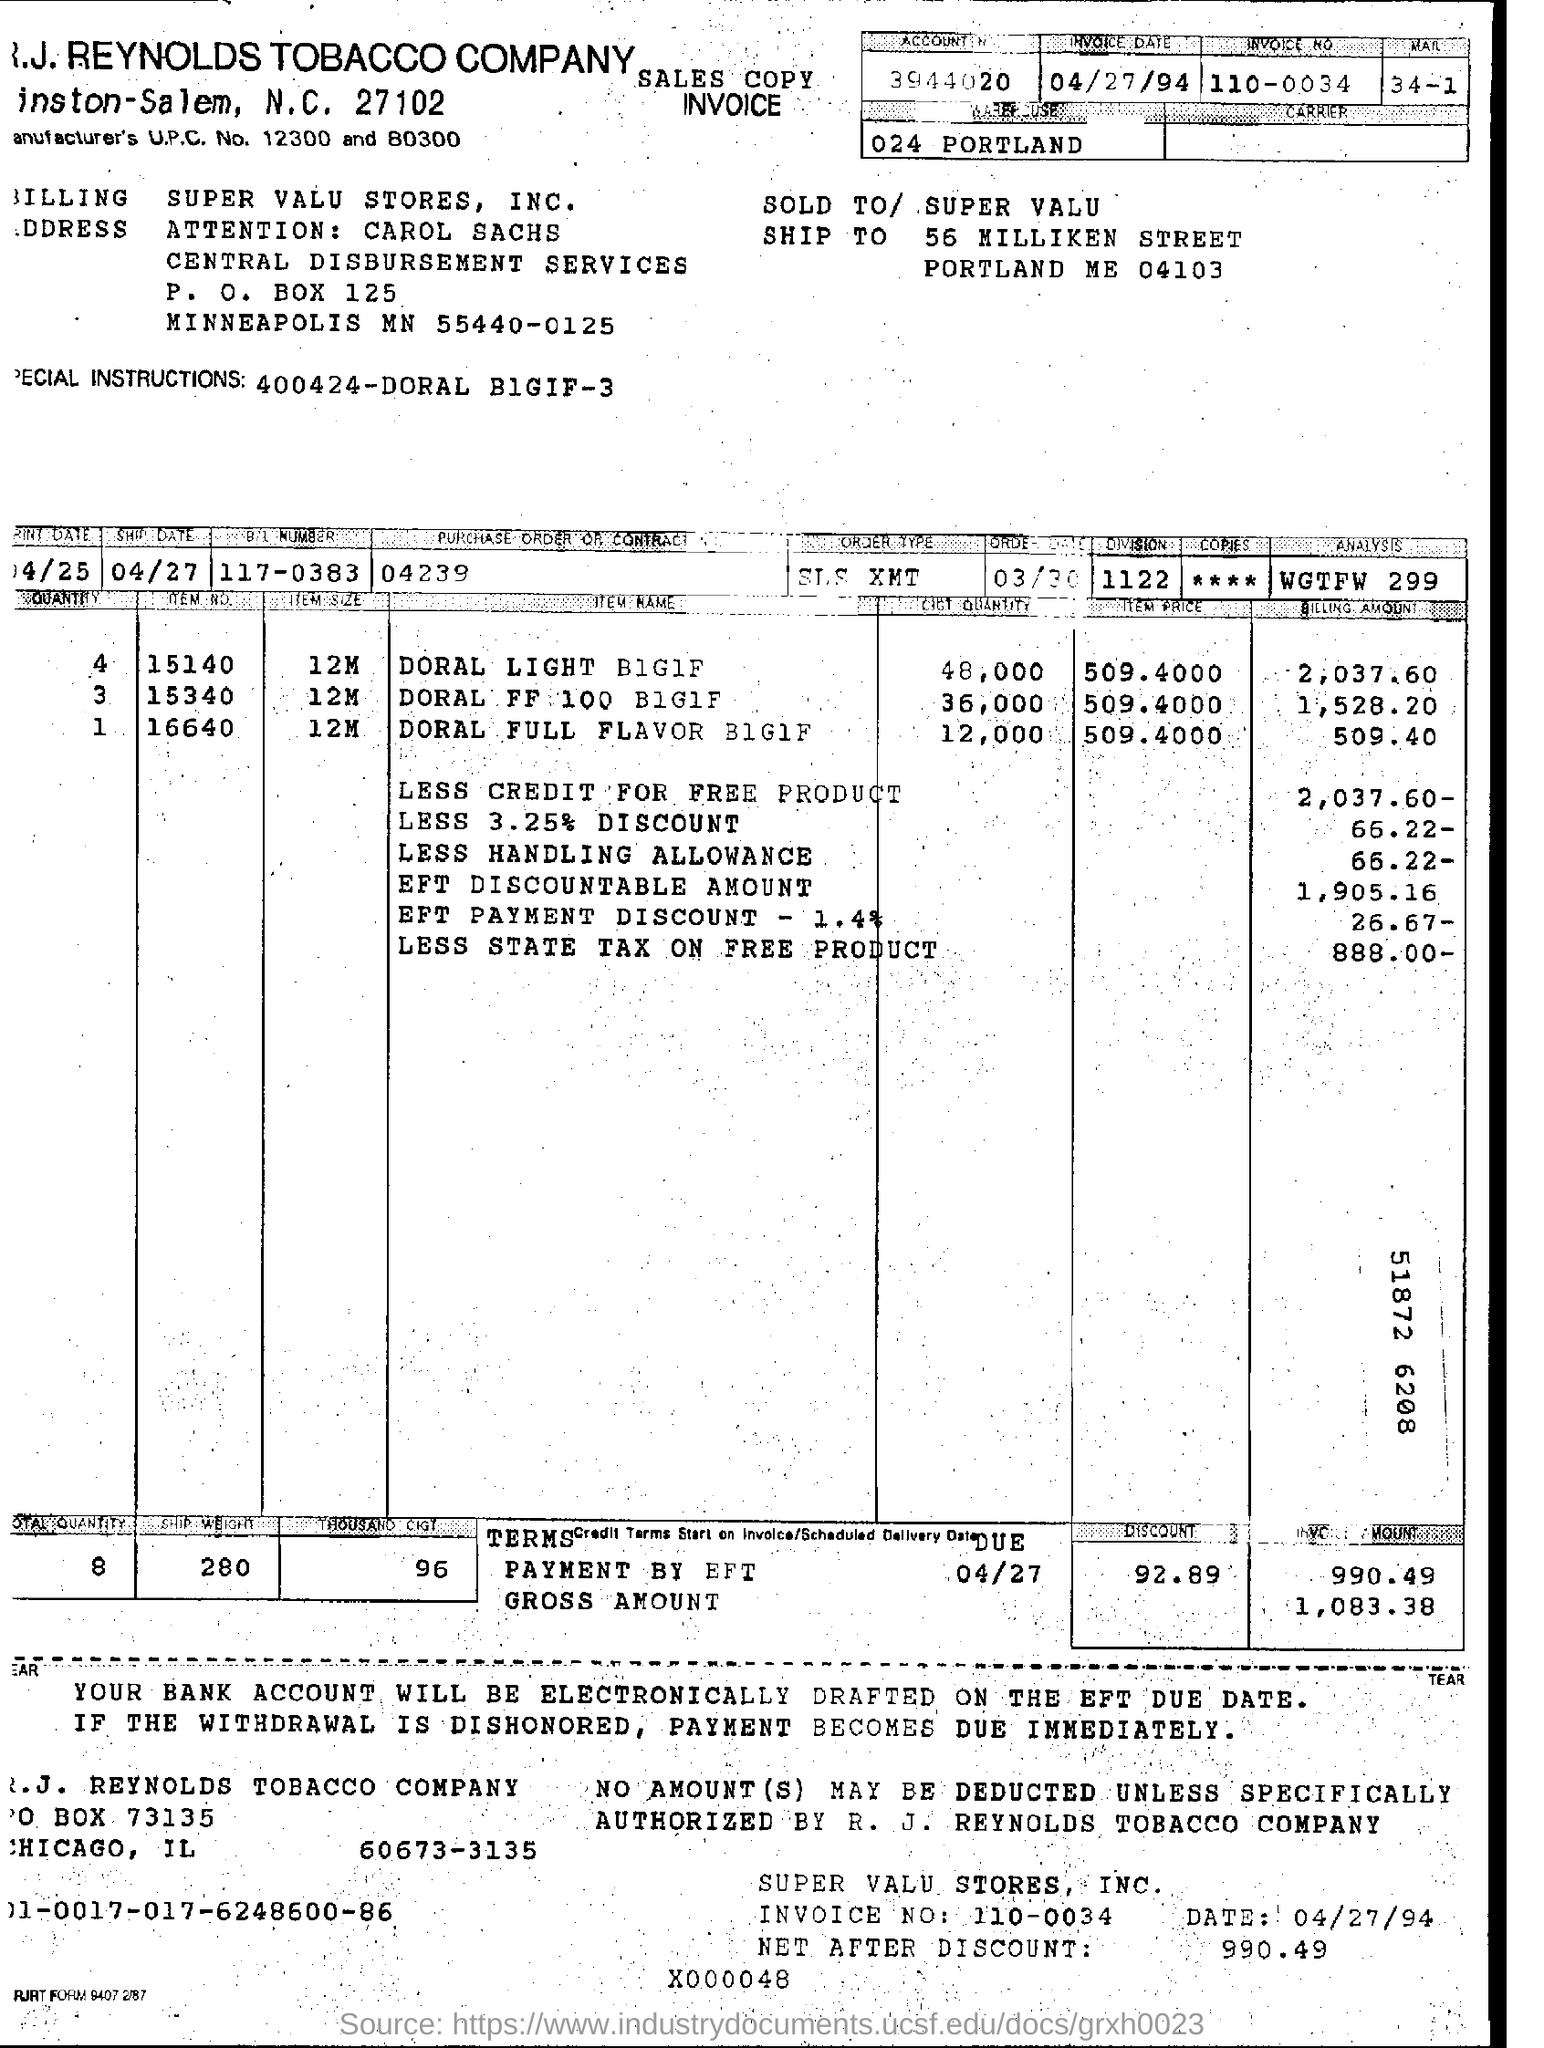Point out several critical features in this image. The invoice date is April 27, 1994. The invoice number is 110-0034... 